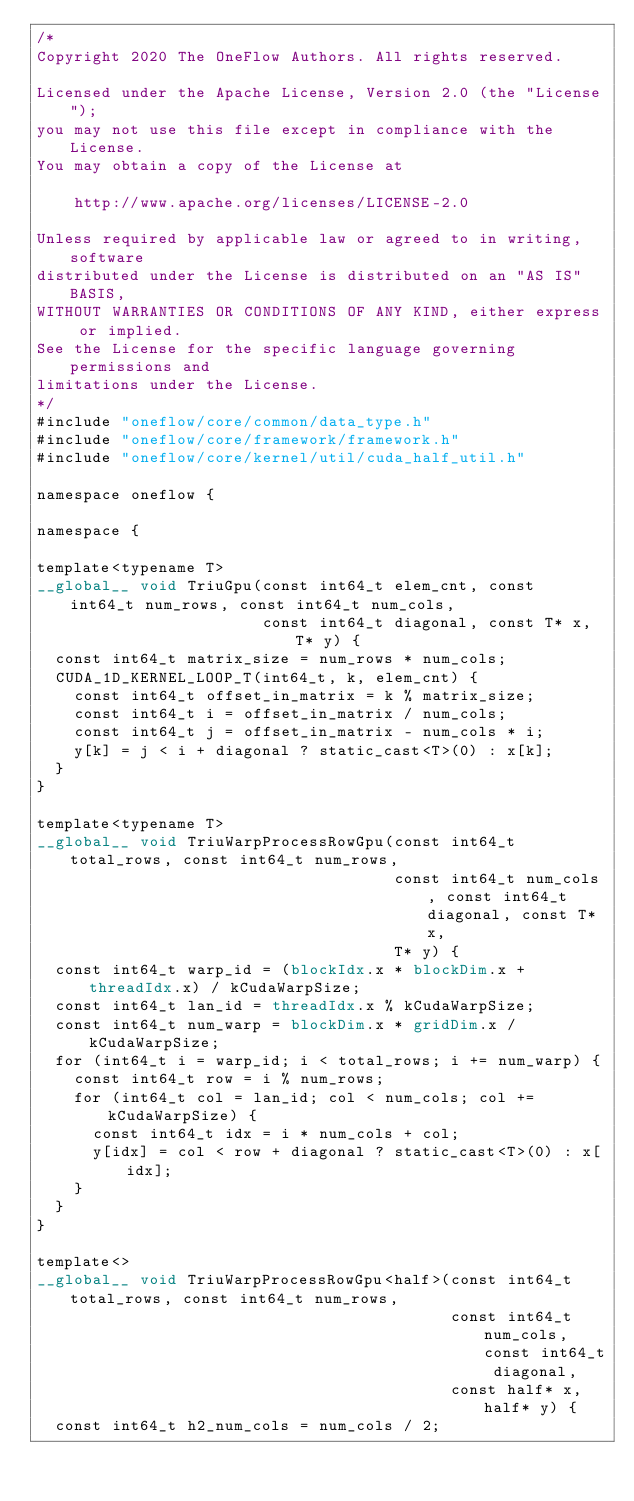<code> <loc_0><loc_0><loc_500><loc_500><_Cuda_>/*
Copyright 2020 The OneFlow Authors. All rights reserved.

Licensed under the Apache License, Version 2.0 (the "License");
you may not use this file except in compliance with the License.
You may obtain a copy of the License at

    http://www.apache.org/licenses/LICENSE-2.0

Unless required by applicable law or agreed to in writing, software
distributed under the License is distributed on an "AS IS" BASIS,
WITHOUT WARRANTIES OR CONDITIONS OF ANY KIND, either express or implied.
See the License for the specific language governing permissions and
limitations under the License.
*/
#include "oneflow/core/common/data_type.h"
#include "oneflow/core/framework/framework.h"
#include "oneflow/core/kernel/util/cuda_half_util.h"

namespace oneflow {

namespace {

template<typename T>
__global__ void TriuGpu(const int64_t elem_cnt, const int64_t num_rows, const int64_t num_cols,
                        const int64_t diagonal, const T* x, T* y) {
  const int64_t matrix_size = num_rows * num_cols;
  CUDA_1D_KERNEL_LOOP_T(int64_t, k, elem_cnt) {
    const int64_t offset_in_matrix = k % matrix_size;
    const int64_t i = offset_in_matrix / num_cols;
    const int64_t j = offset_in_matrix - num_cols * i;
    y[k] = j < i + diagonal ? static_cast<T>(0) : x[k];
  }
}

template<typename T>
__global__ void TriuWarpProcessRowGpu(const int64_t total_rows, const int64_t num_rows,
                                      const int64_t num_cols, const int64_t diagonal, const T* x,
                                      T* y) {
  const int64_t warp_id = (blockIdx.x * blockDim.x + threadIdx.x) / kCudaWarpSize;
  const int64_t lan_id = threadIdx.x % kCudaWarpSize;
  const int64_t num_warp = blockDim.x * gridDim.x / kCudaWarpSize;
  for (int64_t i = warp_id; i < total_rows; i += num_warp) {
    const int64_t row = i % num_rows;
    for (int64_t col = lan_id; col < num_cols; col += kCudaWarpSize) {
      const int64_t idx = i * num_cols + col;
      y[idx] = col < row + diagonal ? static_cast<T>(0) : x[idx];
    }
  }
}

template<>
__global__ void TriuWarpProcessRowGpu<half>(const int64_t total_rows, const int64_t num_rows,
                                            const int64_t num_cols, const int64_t diagonal,
                                            const half* x, half* y) {
  const int64_t h2_num_cols = num_cols / 2;</code> 